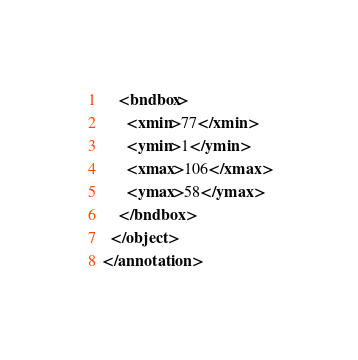Convert code to text. <code><loc_0><loc_0><loc_500><loc_500><_XML_>    <bndbox>
      <xmin>77</xmin>
      <ymin>1</ymin>
      <xmax>106</xmax>
      <ymax>58</ymax>
    </bndbox>
  </object>
</annotation>
</code> 